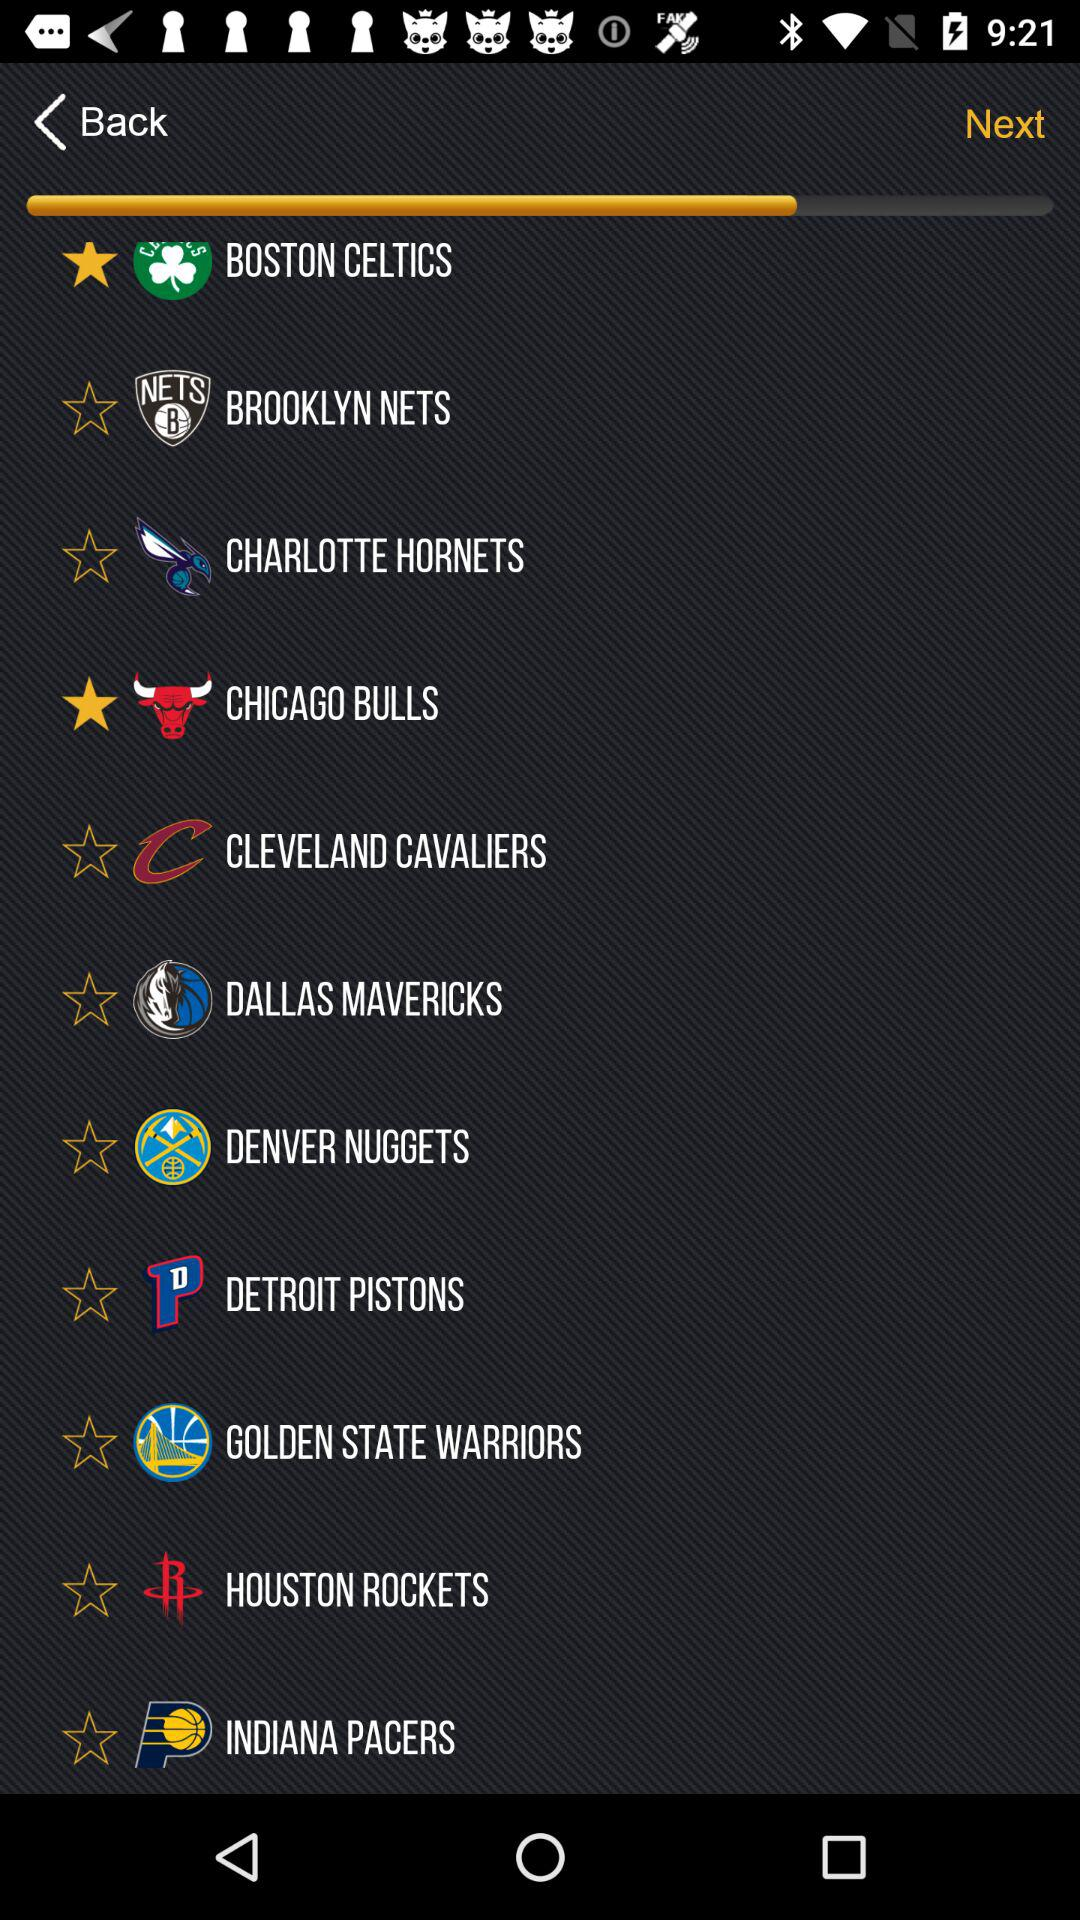What are the star rated team names? The star rated team names are "BOSTON CELTICS" and "CHICAGO BULLS". 